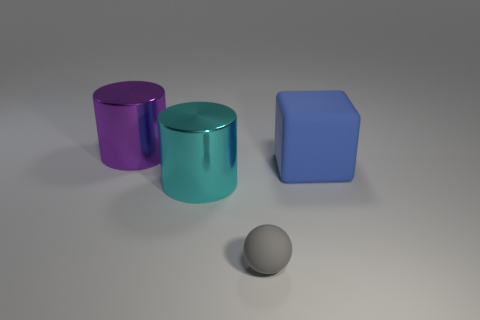Is there anything else that has the same size as the gray sphere?
Ensure brevity in your answer.  No. There is a blue object that is the same size as the cyan metal cylinder; what is its material?
Give a very brief answer. Rubber. What number of big objects are either cyan cylinders or purple cylinders?
Your response must be concise. 2. How many objects are either large objects that are on the right side of the small gray matte object or big things on the right side of the small gray rubber ball?
Offer a terse response. 1. Are there fewer tiny gray rubber balls than tiny blocks?
Provide a short and direct response. No. There is a matte object that is the same size as the cyan cylinder; what shape is it?
Ensure brevity in your answer.  Cube. What number of other things are the same color as the large rubber block?
Make the answer very short. 0. How many large blue cubes are there?
Offer a terse response. 1. What number of big things are both behind the cyan metallic cylinder and left of the tiny ball?
Make the answer very short. 1. What is the material of the big cyan object?
Keep it short and to the point. Metal. 